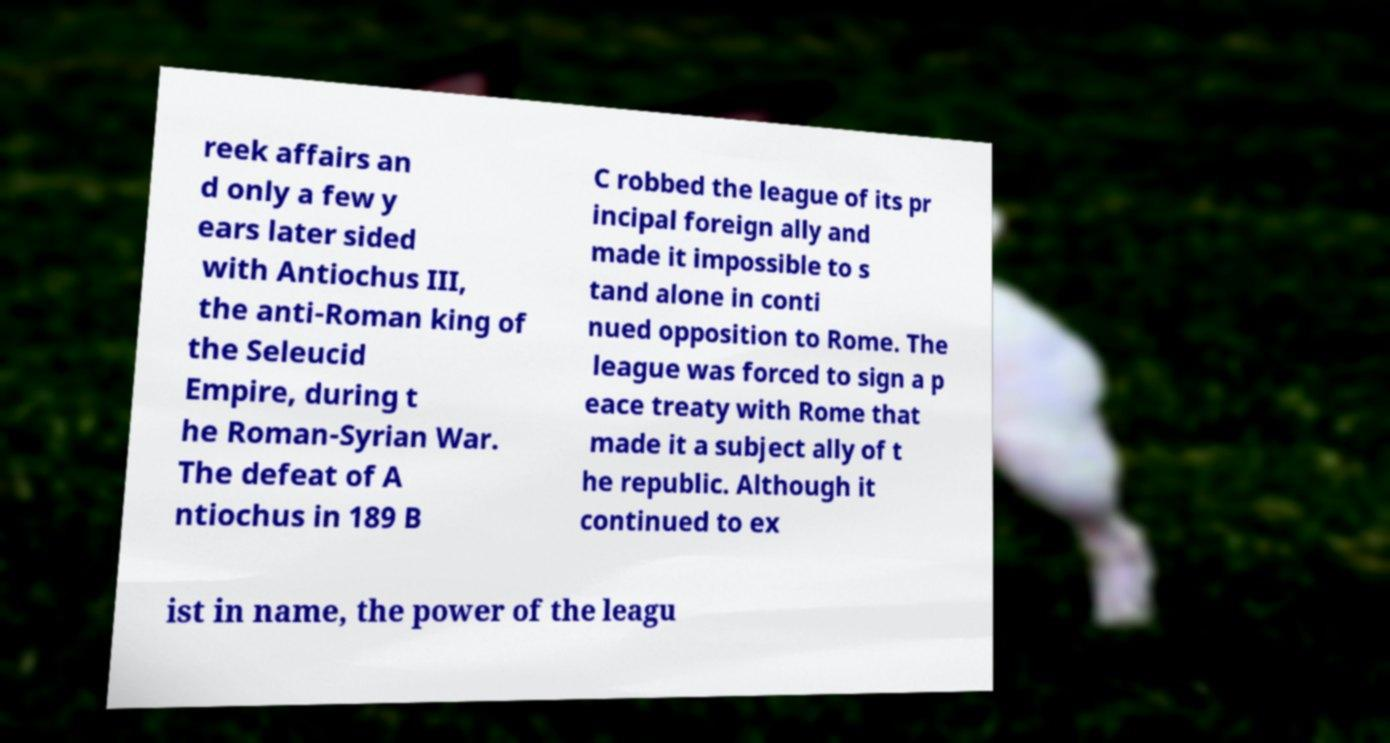What messages or text are displayed in this image? I need them in a readable, typed format. reek affairs an d only a few y ears later sided with Antiochus III, the anti-Roman king of the Seleucid Empire, during t he Roman-Syrian War. The defeat of A ntiochus in 189 B C robbed the league of its pr incipal foreign ally and made it impossible to s tand alone in conti nued opposition to Rome. The league was forced to sign a p eace treaty with Rome that made it a subject ally of t he republic. Although it continued to ex ist in name, the power of the leagu 